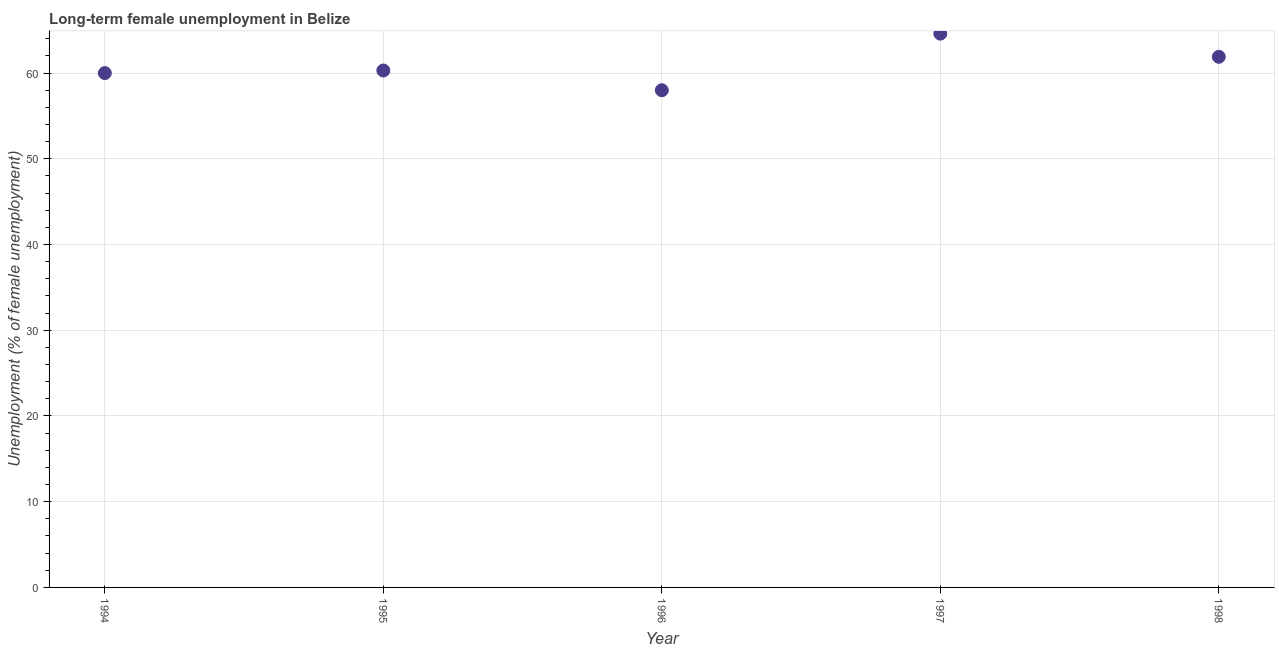What is the long-term female unemployment in 1998?
Provide a short and direct response. 61.9. Across all years, what is the maximum long-term female unemployment?
Your response must be concise. 64.6. In which year was the long-term female unemployment minimum?
Make the answer very short. 1996. What is the sum of the long-term female unemployment?
Your answer should be very brief. 304.8. What is the difference between the long-term female unemployment in 1996 and 1997?
Make the answer very short. -6.6. What is the average long-term female unemployment per year?
Ensure brevity in your answer.  60.96. What is the median long-term female unemployment?
Give a very brief answer. 60.3. In how many years, is the long-term female unemployment greater than 28 %?
Keep it short and to the point. 5. What is the ratio of the long-term female unemployment in 1996 to that in 1997?
Offer a very short reply. 0.9. Is the difference between the long-term female unemployment in 1995 and 1997 greater than the difference between any two years?
Your response must be concise. No. What is the difference between the highest and the second highest long-term female unemployment?
Your answer should be compact. 2.7. Is the sum of the long-term female unemployment in 1997 and 1998 greater than the maximum long-term female unemployment across all years?
Give a very brief answer. Yes. What is the difference between the highest and the lowest long-term female unemployment?
Your answer should be compact. 6.6. In how many years, is the long-term female unemployment greater than the average long-term female unemployment taken over all years?
Your answer should be very brief. 2. How many dotlines are there?
Provide a succinct answer. 1. How many years are there in the graph?
Your answer should be very brief. 5. What is the difference between two consecutive major ticks on the Y-axis?
Your answer should be compact. 10. Are the values on the major ticks of Y-axis written in scientific E-notation?
Your answer should be very brief. No. Does the graph contain grids?
Your answer should be very brief. Yes. What is the title of the graph?
Keep it short and to the point. Long-term female unemployment in Belize. What is the label or title of the X-axis?
Keep it short and to the point. Year. What is the label or title of the Y-axis?
Your answer should be compact. Unemployment (% of female unemployment). What is the Unemployment (% of female unemployment) in 1994?
Your answer should be very brief. 60. What is the Unemployment (% of female unemployment) in 1995?
Ensure brevity in your answer.  60.3. What is the Unemployment (% of female unemployment) in 1997?
Provide a short and direct response. 64.6. What is the Unemployment (% of female unemployment) in 1998?
Offer a very short reply. 61.9. What is the difference between the Unemployment (% of female unemployment) in 1994 and 1998?
Offer a terse response. -1.9. What is the difference between the Unemployment (% of female unemployment) in 1995 and 1996?
Give a very brief answer. 2.3. What is the difference between the Unemployment (% of female unemployment) in 1995 and 1998?
Your response must be concise. -1.6. What is the difference between the Unemployment (% of female unemployment) in 1996 and 1998?
Give a very brief answer. -3.9. What is the ratio of the Unemployment (% of female unemployment) in 1994 to that in 1996?
Ensure brevity in your answer.  1.03. What is the ratio of the Unemployment (% of female unemployment) in 1994 to that in 1997?
Your response must be concise. 0.93. What is the ratio of the Unemployment (% of female unemployment) in 1995 to that in 1997?
Offer a terse response. 0.93. What is the ratio of the Unemployment (% of female unemployment) in 1995 to that in 1998?
Make the answer very short. 0.97. What is the ratio of the Unemployment (% of female unemployment) in 1996 to that in 1997?
Make the answer very short. 0.9. What is the ratio of the Unemployment (% of female unemployment) in 1996 to that in 1998?
Provide a short and direct response. 0.94. What is the ratio of the Unemployment (% of female unemployment) in 1997 to that in 1998?
Provide a short and direct response. 1.04. 